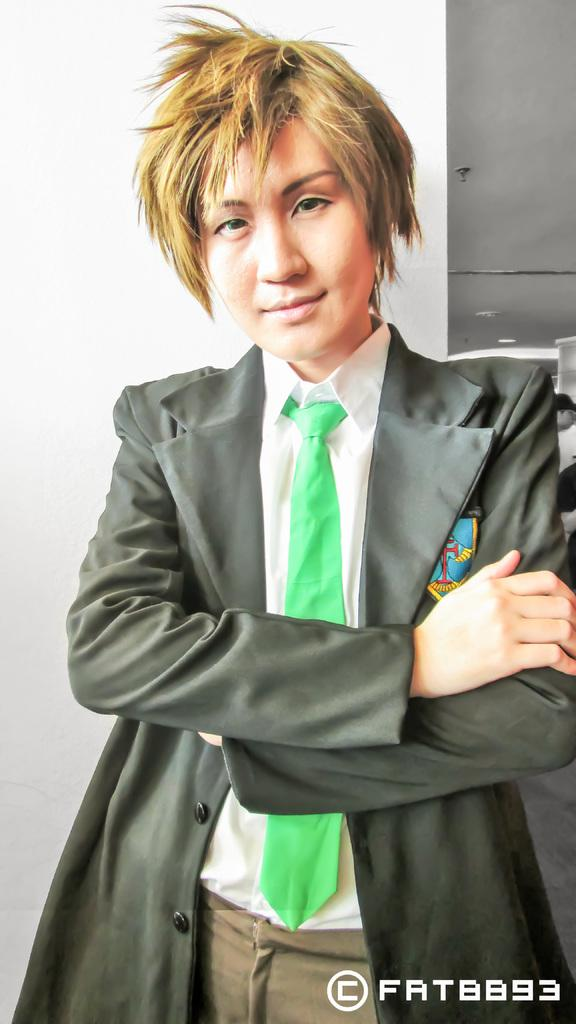Who or what is present in the image? There is a person in the image. What is the person wearing? The person is wearing a black suit and a green tie. What can be seen in the background of the image? There is a wall in the background of the image. How many dogs are sitting on the person's lap in the image? There are no dogs present in the image. What type of advice can be seen written on the wall in the image? There is no advice written on the wall in the image; it is just a plain wall in the background. 